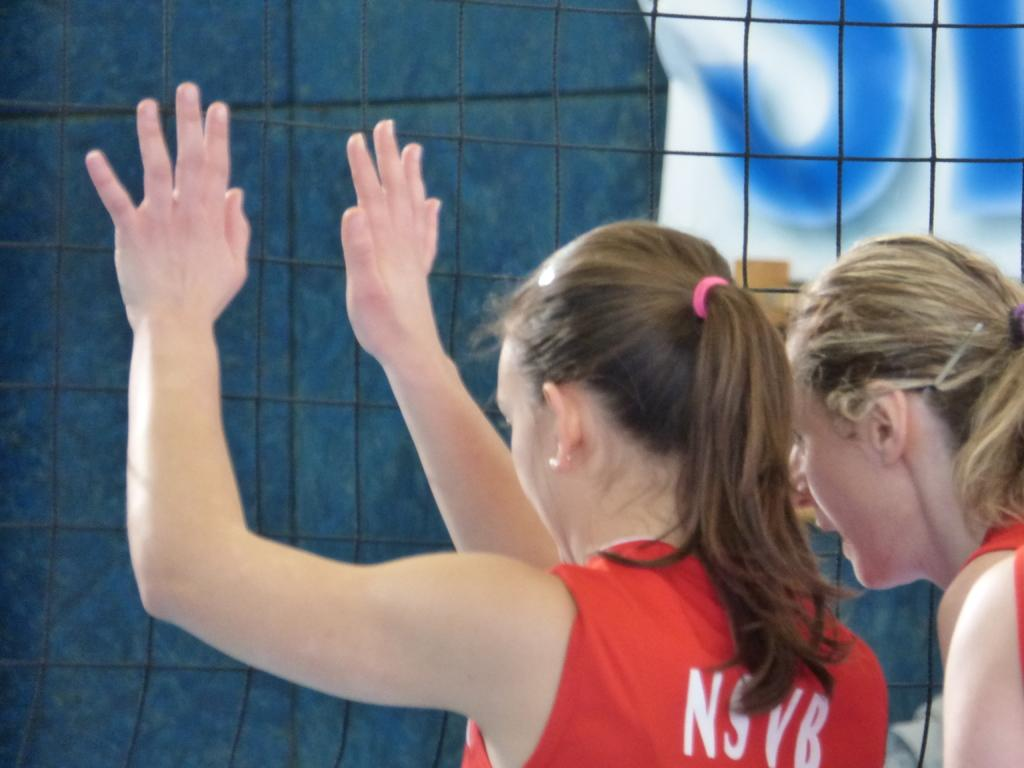How many people are in the image? There are two persons in the image. What is the person wearing on the left side of the image wearing? The person on the left side of the image is wearing a red dress. What type of fencing can be seen in the image? There is net fencing in the image. What colors are present in the background of the image? The background of the image has blue and white colors. What type of needle is the person holding in the image? There is no needle present in the image. Can you see any cattle in the image? There are no cattle present in the image. 